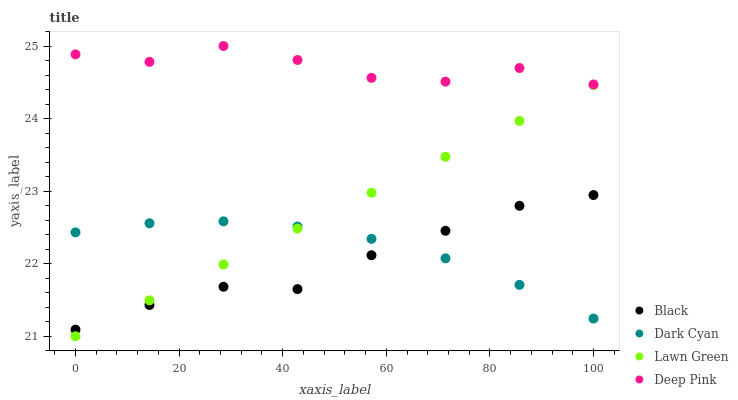Does Black have the minimum area under the curve?
Answer yes or no. Yes. Does Deep Pink have the maximum area under the curve?
Answer yes or no. Yes. Does Lawn Green have the minimum area under the curve?
Answer yes or no. No. Does Lawn Green have the maximum area under the curve?
Answer yes or no. No. Is Lawn Green the smoothest?
Answer yes or no. Yes. Is Deep Pink the roughest?
Answer yes or no. Yes. Is Deep Pink the smoothest?
Answer yes or no. No. Is Lawn Green the roughest?
Answer yes or no. No. Does Lawn Green have the lowest value?
Answer yes or no. Yes. Does Deep Pink have the lowest value?
Answer yes or no. No. Does Deep Pink have the highest value?
Answer yes or no. Yes. Does Lawn Green have the highest value?
Answer yes or no. No. Is Black less than Deep Pink?
Answer yes or no. Yes. Is Deep Pink greater than Lawn Green?
Answer yes or no. Yes. Does Dark Cyan intersect Black?
Answer yes or no. Yes. Is Dark Cyan less than Black?
Answer yes or no. No. Is Dark Cyan greater than Black?
Answer yes or no. No. Does Black intersect Deep Pink?
Answer yes or no. No. 